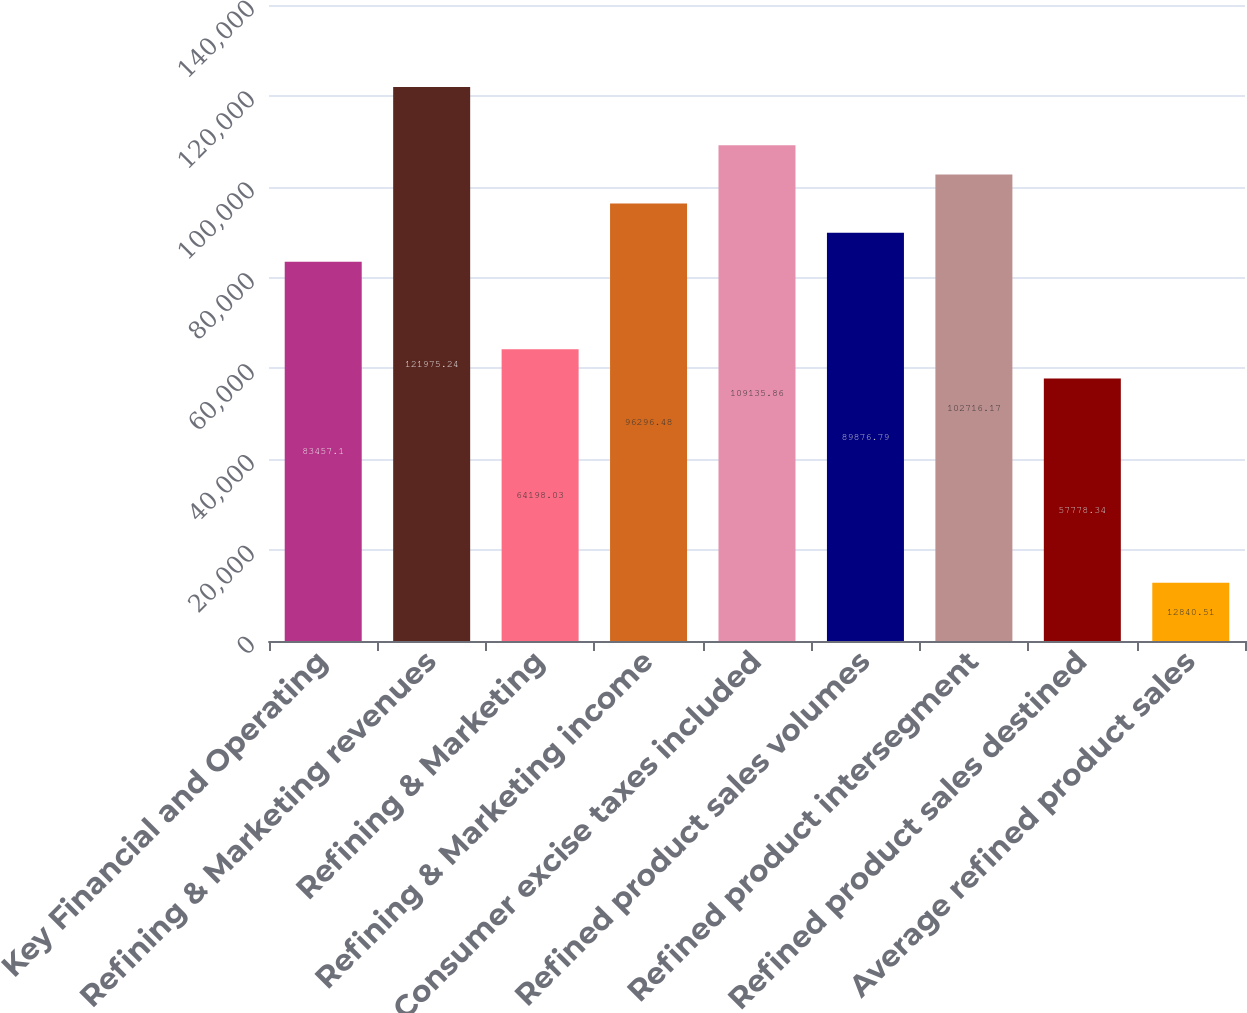Convert chart to OTSL. <chart><loc_0><loc_0><loc_500><loc_500><bar_chart><fcel>Key Financial and Operating<fcel>Refining & Marketing revenues<fcel>Refining & Marketing<fcel>Refining & Marketing income<fcel>Consumer excise taxes included<fcel>Refined product sales volumes<fcel>Refined product intersegment<fcel>Refined product sales destined<fcel>Average refined product sales<nl><fcel>83457.1<fcel>121975<fcel>64198<fcel>96296.5<fcel>109136<fcel>89876.8<fcel>102716<fcel>57778.3<fcel>12840.5<nl></chart> 